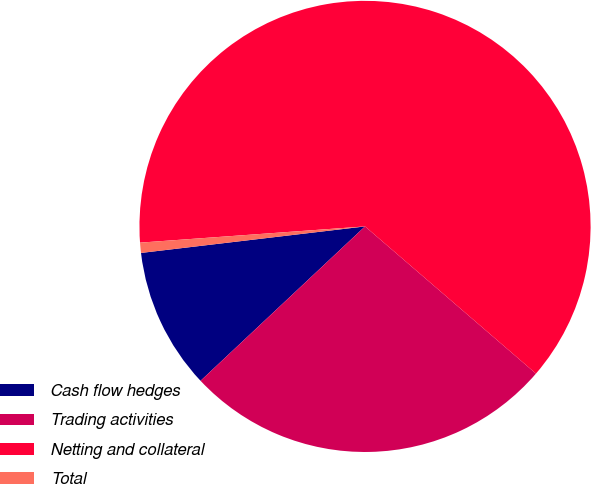Convert chart to OTSL. <chart><loc_0><loc_0><loc_500><loc_500><pie_chart><fcel>Cash flow hedges<fcel>Trading activities<fcel>Netting and collateral<fcel>Total<nl><fcel>10.12%<fcel>26.69%<fcel>62.46%<fcel>0.73%<nl></chart> 